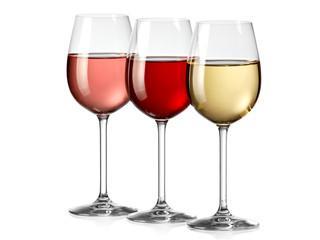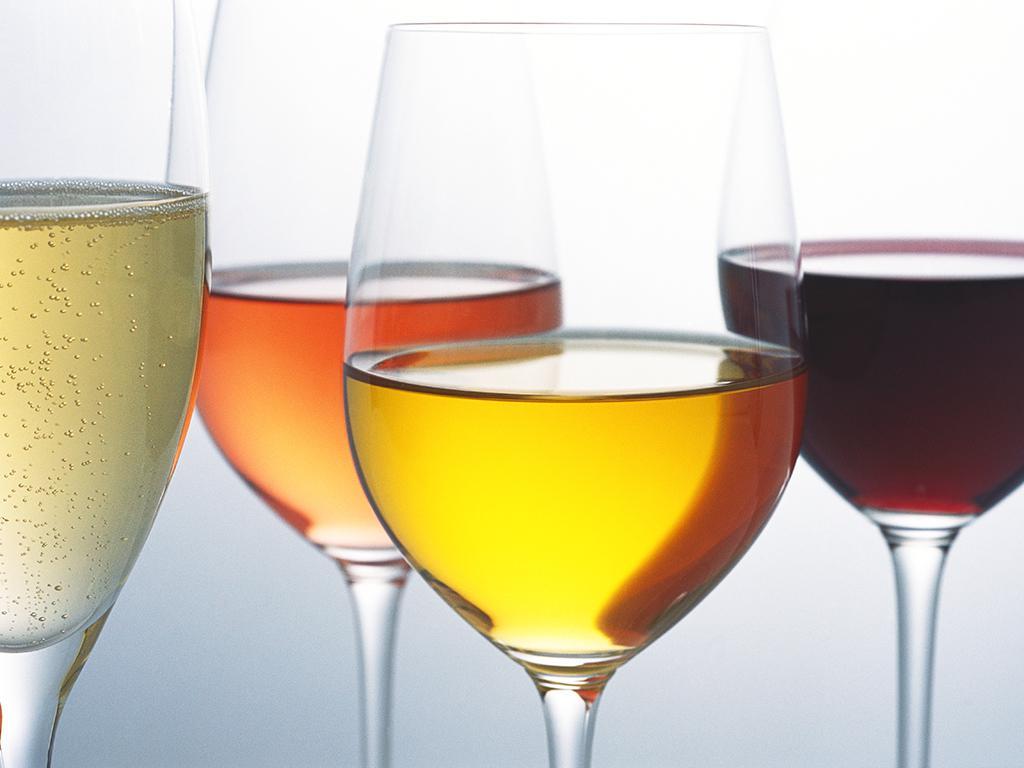The first image is the image on the left, the second image is the image on the right. Given the left and right images, does the statement "One image contains four glasses of different colors of wine." hold true? Answer yes or no. Yes. The first image is the image on the left, the second image is the image on the right. Examine the images to the left and right. Is the description "There are four glasses of liquid in one of the images." accurate? Answer yes or no. Yes. 